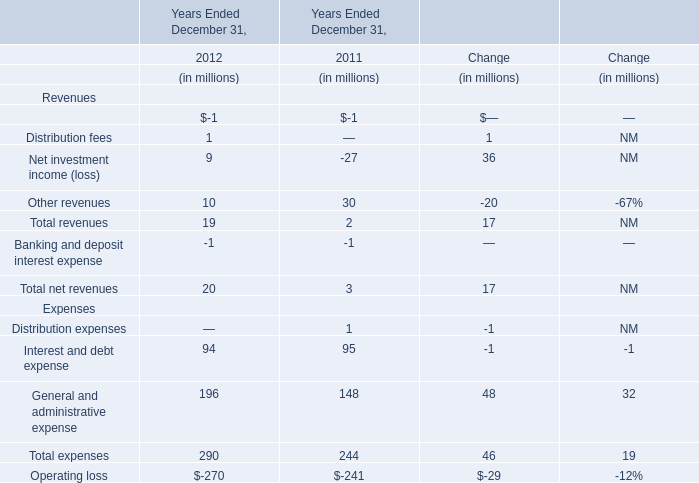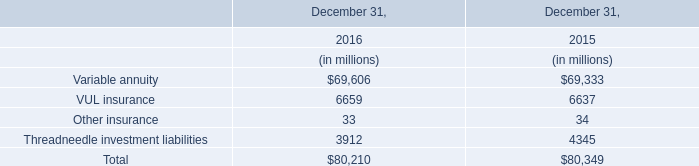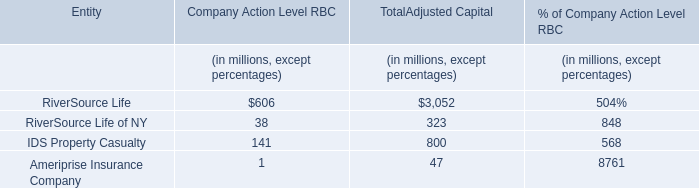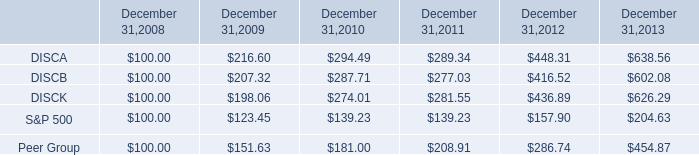What's the average of the revenues in the years where net investment income is positive? (in million) 
Computations: (19 / 4)
Answer: 4.75. 